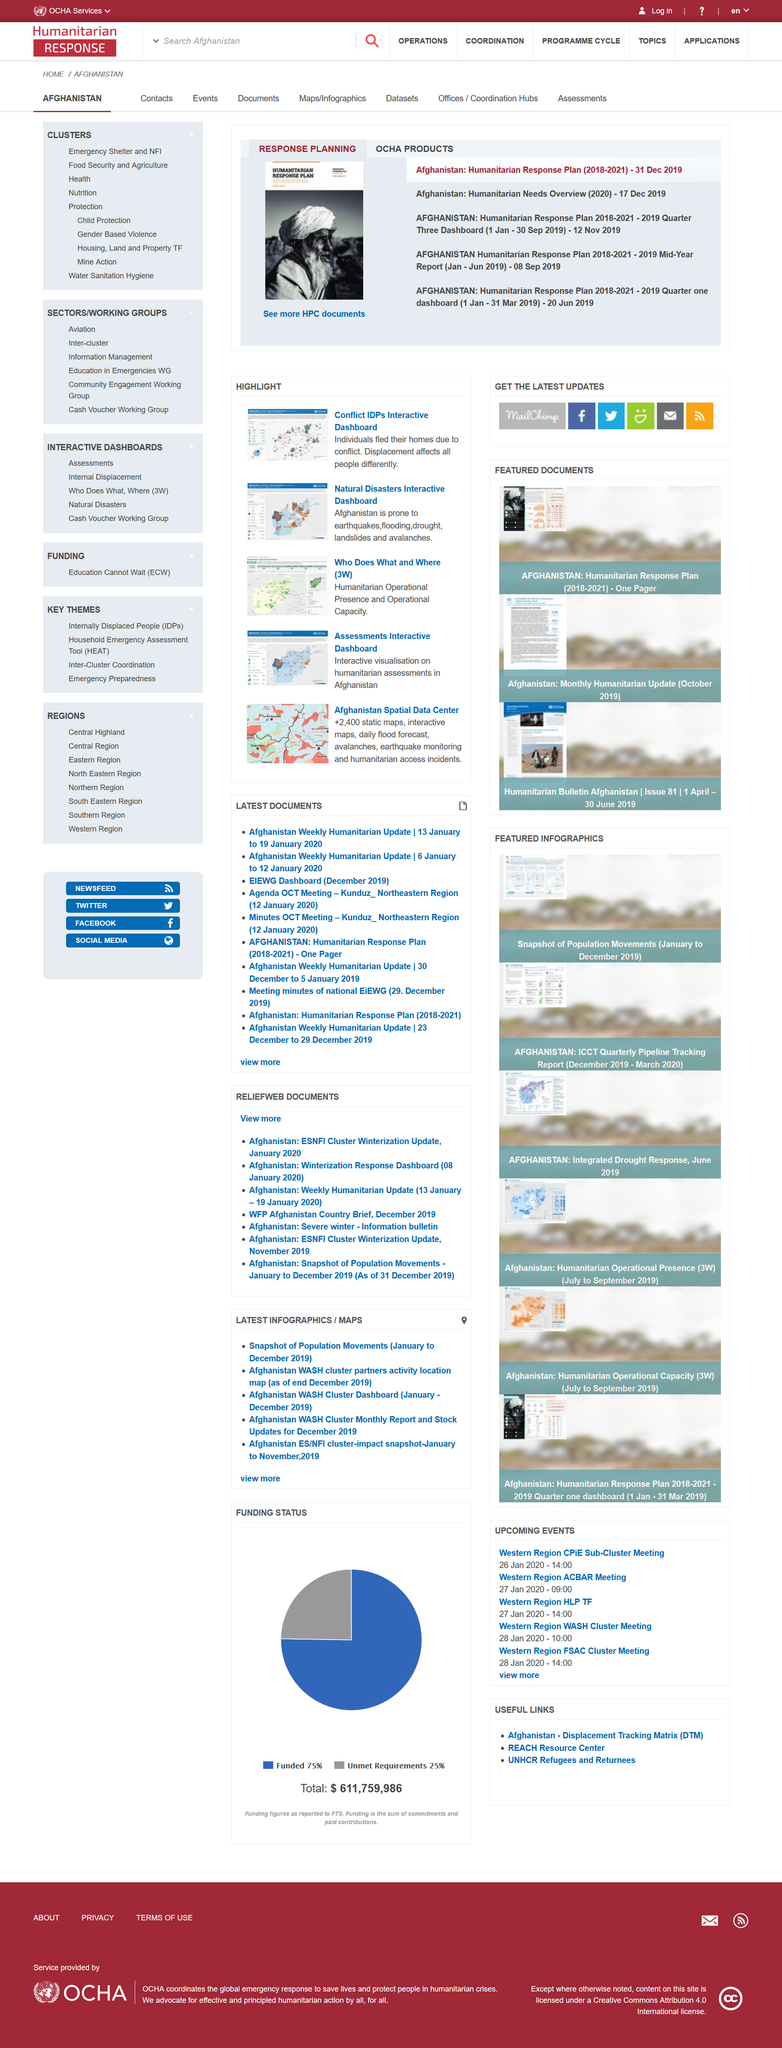Identify some key points in this picture. The title of the document is Humanitarian Response Plan for [insert relevant information here]. This document is a HPC document. This document belongs to the category of "Response Planning. 